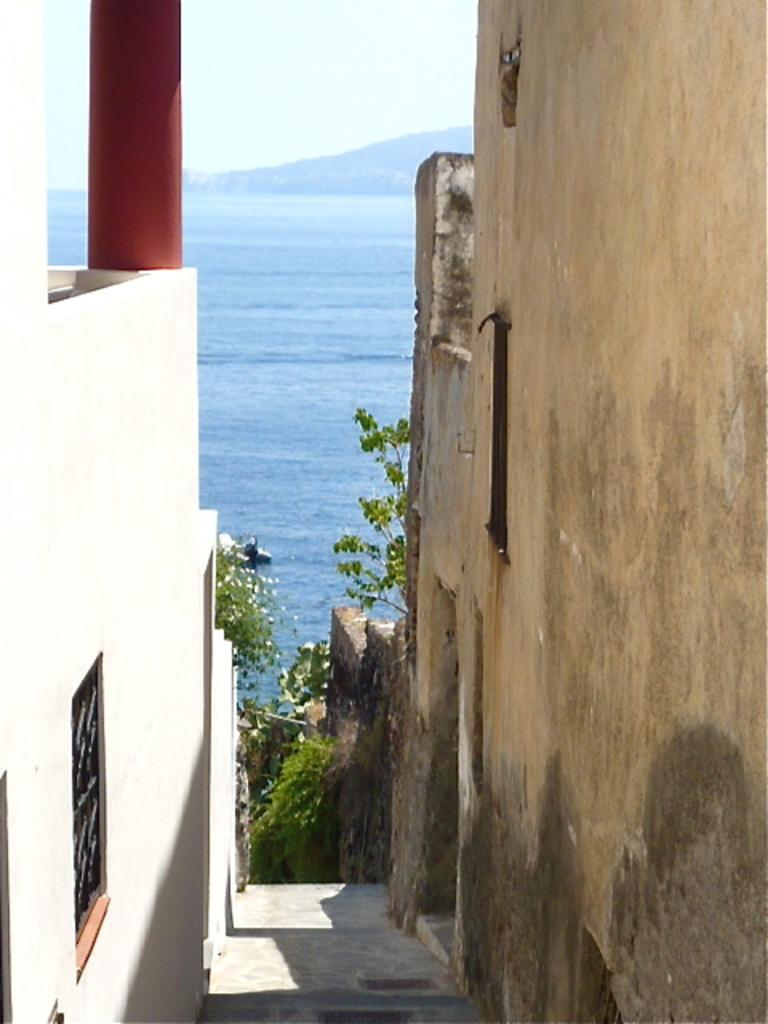What is the main feature in the middle of the image? There is a path in the middle of the image. What can be seen on either side of the path? There are buildings on either side of the path. What architectural feature can be seen on the buildings? There are windows on the buildings. What type of natural elements can be seen in the background of the image? There are plants, water, and a mountain visible in the background. What is visible above the buildings and natural elements in the background? The sky is visible in the background. What type of pen is being used to write on the frame in the image? There is no pen or frame present in the image. 